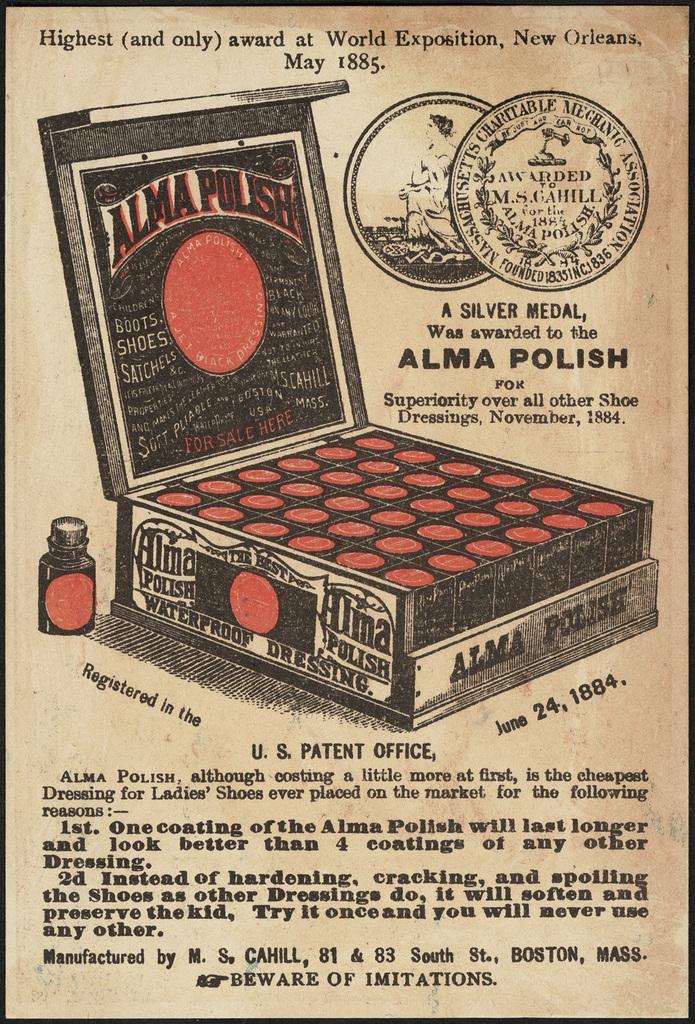What type of polish?
Provide a short and direct response. Alma. What is the brand name of the polish?
Offer a terse response. Alma. 